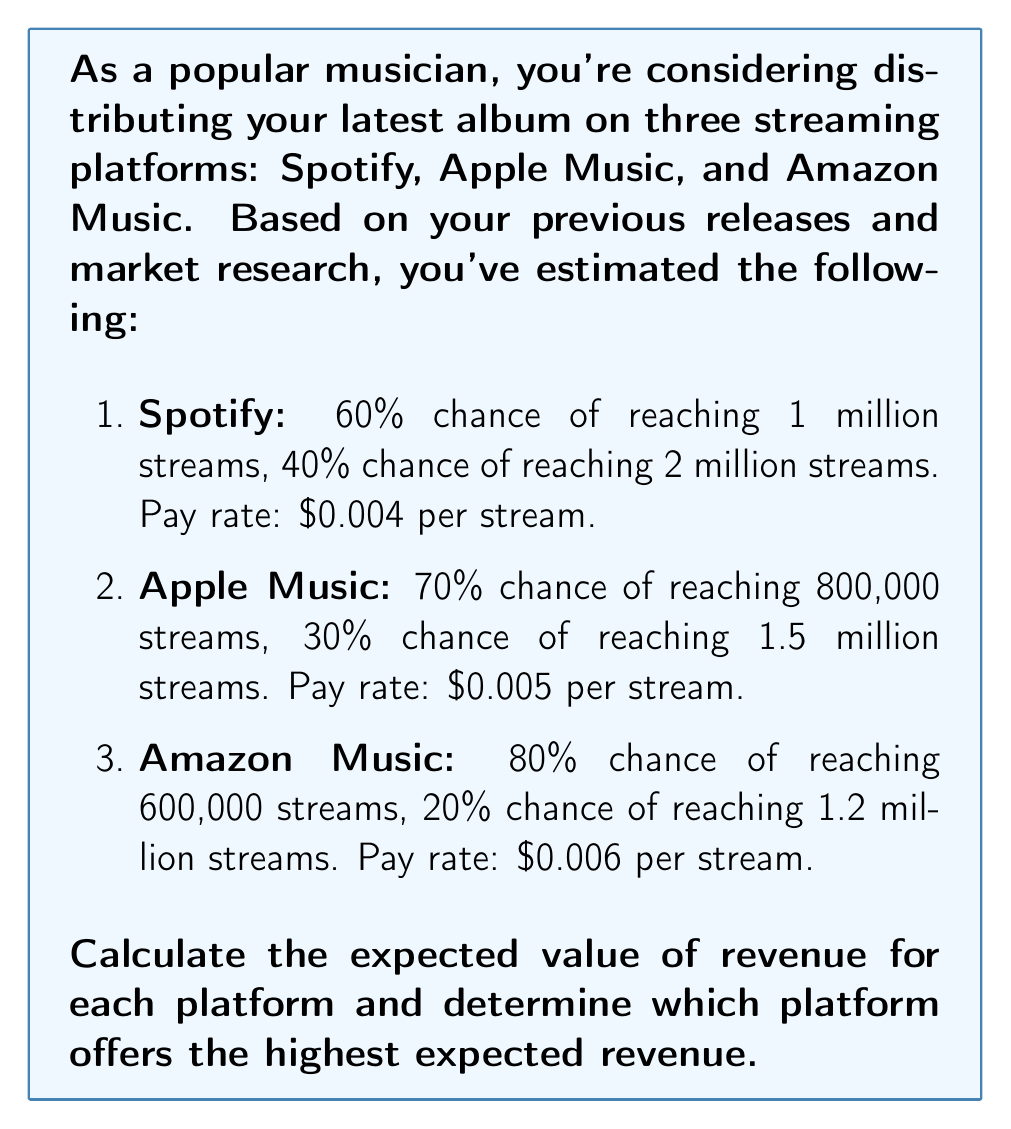Teach me how to tackle this problem. To solve this problem, we need to calculate the expected value of revenue for each platform using the given probabilities and pay rates. Let's go through each platform step by step:

1. Spotify:
   Expected streams = (0.60 × 1,000,000) + (0.40 × 2,000,000)
   $$ E(S_{spotify}) = 0.60 \times 1,000,000 + 0.40 \times 2,000,000 = 1,400,000 $$
   Expected revenue = Expected streams × Pay rate
   $$ E(R_{spotify}) = 1,400,000 \times \$0.004 = \$5,600 $$

2. Apple Music:
   Expected streams = (0.70 × 800,000) + (0.30 × 1,500,000)
   $$ E(S_{apple}) = 0.70 \times 800,000 + 0.30 \times 1,500,000 = 1,010,000 $$
   Expected revenue = Expected streams × Pay rate
   $$ E(R_{apple}) = 1,010,000 \times \$0.005 = \$5,050 $$

3. Amazon Music:
   Expected streams = (0.80 × 600,000) + (0.20 × 1,200,000)
   $$ E(S_{amazon}) = 0.80 \times 600,000 + 0.20 \times 1,200,000 = 720,000 $$
   Expected revenue = Expected streams × Pay rate
   $$ E(R_{amazon}) = 720,000 \times \$0.006 = \$4,320 $$

Comparing the expected revenues:
$$ E(R_{spotify}) = \$5,600 $$
$$ E(R_{apple}) = \$5,050 $$
$$ E(R_{amazon}) = \$4,320 $$

Therefore, Spotify offers the highest expected revenue at $5,600.
Answer: Spotify: $5,600; Apple Music: $5,050; Amazon Music: $4,320. Spotify offers the highest expected revenue. 